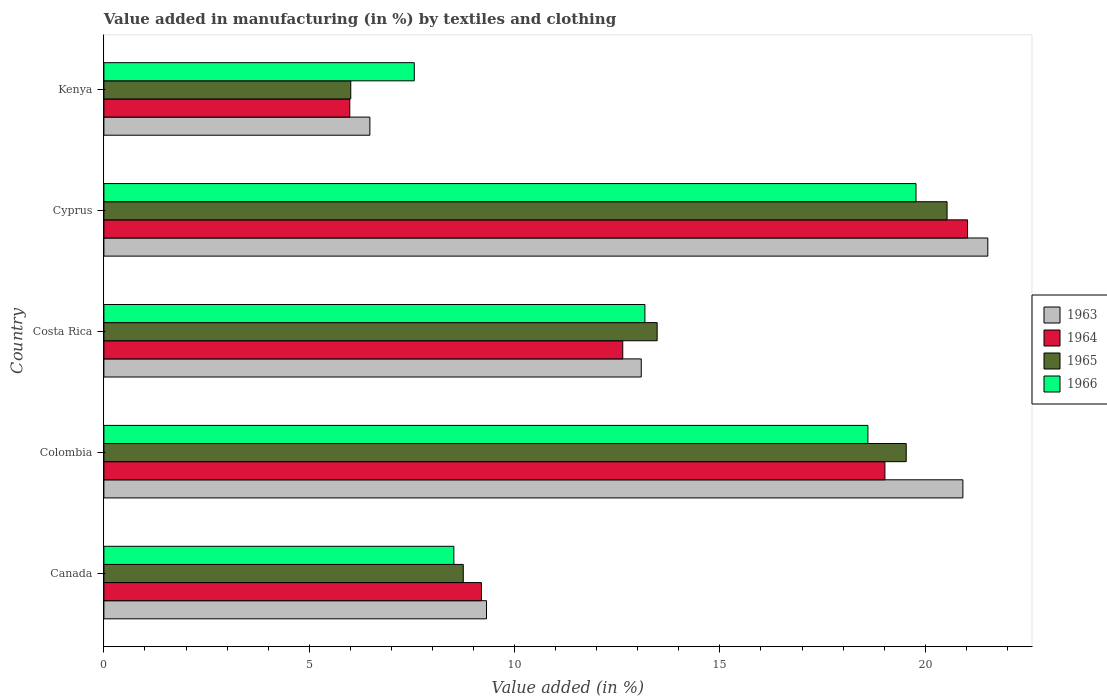How many groups of bars are there?
Make the answer very short. 5. Are the number of bars per tick equal to the number of legend labels?
Keep it short and to the point. Yes. How many bars are there on the 1st tick from the top?
Provide a short and direct response. 4. How many bars are there on the 3rd tick from the bottom?
Offer a very short reply. 4. What is the percentage of value added in manufacturing by textiles and clothing in 1963 in Canada?
Provide a short and direct response. 9.32. Across all countries, what is the maximum percentage of value added in manufacturing by textiles and clothing in 1963?
Provide a succinct answer. 21.52. Across all countries, what is the minimum percentage of value added in manufacturing by textiles and clothing in 1964?
Your answer should be compact. 5.99. In which country was the percentage of value added in manufacturing by textiles and clothing in 1965 maximum?
Give a very brief answer. Cyprus. In which country was the percentage of value added in manufacturing by textiles and clothing in 1966 minimum?
Provide a short and direct response. Kenya. What is the total percentage of value added in manufacturing by textiles and clothing in 1966 in the graph?
Your response must be concise. 67.63. What is the difference between the percentage of value added in manufacturing by textiles and clothing in 1966 in Canada and that in Colombia?
Give a very brief answer. -10.08. What is the difference between the percentage of value added in manufacturing by textiles and clothing in 1965 in Colombia and the percentage of value added in manufacturing by textiles and clothing in 1964 in Cyprus?
Offer a very short reply. -1.49. What is the average percentage of value added in manufacturing by textiles and clothing in 1963 per country?
Keep it short and to the point. 14.26. What is the difference between the percentage of value added in manufacturing by textiles and clothing in 1965 and percentage of value added in manufacturing by textiles and clothing in 1963 in Colombia?
Ensure brevity in your answer.  -1.38. What is the ratio of the percentage of value added in manufacturing by textiles and clothing in 1966 in Colombia to that in Costa Rica?
Ensure brevity in your answer.  1.41. What is the difference between the highest and the second highest percentage of value added in manufacturing by textiles and clothing in 1964?
Ensure brevity in your answer.  2.01. What is the difference between the highest and the lowest percentage of value added in manufacturing by textiles and clothing in 1963?
Your answer should be very brief. 15.05. Is it the case that in every country, the sum of the percentage of value added in manufacturing by textiles and clothing in 1965 and percentage of value added in manufacturing by textiles and clothing in 1966 is greater than the sum of percentage of value added in manufacturing by textiles and clothing in 1964 and percentage of value added in manufacturing by textiles and clothing in 1963?
Give a very brief answer. No. What does the 1st bar from the top in Colombia represents?
Keep it short and to the point. 1966. What does the 3rd bar from the bottom in Costa Rica represents?
Your answer should be very brief. 1965. Is it the case that in every country, the sum of the percentage of value added in manufacturing by textiles and clothing in 1964 and percentage of value added in manufacturing by textiles and clothing in 1963 is greater than the percentage of value added in manufacturing by textiles and clothing in 1965?
Your answer should be compact. Yes. How many bars are there?
Your response must be concise. 20. Are all the bars in the graph horizontal?
Provide a succinct answer. Yes. What is the difference between two consecutive major ticks on the X-axis?
Provide a succinct answer. 5. Are the values on the major ticks of X-axis written in scientific E-notation?
Make the answer very short. No. Does the graph contain any zero values?
Ensure brevity in your answer.  No. Where does the legend appear in the graph?
Keep it short and to the point. Center right. What is the title of the graph?
Offer a terse response. Value added in manufacturing (in %) by textiles and clothing. Does "2007" appear as one of the legend labels in the graph?
Provide a succinct answer. No. What is the label or title of the X-axis?
Keep it short and to the point. Value added (in %). What is the Value added (in %) in 1963 in Canada?
Your answer should be compact. 9.32. What is the Value added (in %) in 1964 in Canada?
Make the answer very short. 9.19. What is the Value added (in %) of 1965 in Canada?
Keep it short and to the point. 8.75. What is the Value added (in %) in 1966 in Canada?
Ensure brevity in your answer.  8.52. What is the Value added (in %) of 1963 in Colombia?
Give a very brief answer. 20.92. What is the Value added (in %) of 1964 in Colombia?
Give a very brief answer. 19.02. What is the Value added (in %) of 1965 in Colombia?
Give a very brief answer. 19.54. What is the Value added (in %) of 1966 in Colombia?
Provide a succinct answer. 18.6. What is the Value added (in %) of 1963 in Costa Rica?
Give a very brief answer. 13.08. What is the Value added (in %) in 1964 in Costa Rica?
Offer a terse response. 12.63. What is the Value added (in %) in 1965 in Costa Rica?
Provide a succinct answer. 13.47. What is the Value added (in %) of 1966 in Costa Rica?
Make the answer very short. 13.17. What is the Value added (in %) in 1963 in Cyprus?
Your answer should be compact. 21.52. What is the Value added (in %) of 1964 in Cyprus?
Provide a short and direct response. 21.03. What is the Value added (in %) in 1965 in Cyprus?
Keep it short and to the point. 20.53. What is the Value added (in %) in 1966 in Cyprus?
Provide a short and direct response. 19.78. What is the Value added (in %) of 1963 in Kenya?
Offer a terse response. 6.48. What is the Value added (in %) of 1964 in Kenya?
Provide a short and direct response. 5.99. What is the Value added (in %) in 1965 in Kenya?
Provide a succinct answer. 6.01. What is the Value added (in %) in 1966 in Kenya?
Keep it short and to the point. 7.56. Across all countries, what is the maximum Value added (in %) of 1963?
Provide a short and direct response. 21.52. Across all countries, what is the maximum Value added (in %) in 1964?
Your answer should be compact. 21.03. Across all countries, what is the maximum Value added (in %) in 1965?
Offer a very short reply. 20.53. Across all countries, what is the maximum Value added (in %) of 1966?
Your answer should be very brief. 19.78. Across all countries, what is the minimum Value added (in %) of 1963?
Keep it short and to the point. 6.48. Across all countries, what is the minimum Value added (in %) of 1964?
Offer a very short reply. 5.99. Across all countries, what is the minimum Value added (in %) in 1965?
Make the answer very short. 6.01. Across all countries, what is the minimum Value added (in %) of 1966?
Offer a terse response. 7.56. What is the total Value added (in %) of 1963 in the graph?
Offer a very short reply. 71.32. What is the total Value added (in %) in 1964 in the graph?
Ensure brevity in your answer.  67.86. What is the total Value added (in %) in 1965 in the graph?
Offer a very short reply. 68.3. What is the total Value added (in %) in 1966 in the graph?
Keep it short and to the point. 67.63. What is the difference between the Value added (in %) of 1963 in Canada and that in Colombia?
Offer a terse response. -11.6. What is the difference between the Value added (in %) of 1964 in Canada and that in Colombia?
Your answer should be compact. -9.82. What is the difference between the Value added (in %) of 1965 in Canada and that in Colombia?
Your response must be concise. -10.79. What is the difference between the Value added (in %) in 1966 in Canada and that in Colombia?
Provide a short and direct response. -10.08. What is the difference between the Value added (in %) of 1963 in Canada and that in Costa Rica?
Your answer should be compact. -3.77. What is the difference between the Value added (in %) in 1964 in Canada and that in Costa Rica?
Offer a very short reply. -3.44. What is the difference between the Value added (in %) of 1965 in Canada and that in Costa Rica?
Offer a terse response. -4.72. What is the difference between the Value added (in %) in 1966 in Canada and that in Costa Rica?
Give a very brief answer. -4.65. What is the difference between the Value added (in %) in 1963 in Canada and that in Cyprus?
Your response must be concise. -12.21. What is the difference between the Value added (in %) in 1964 in Canada and that in Cyprus?
Give a very brief answer. -11.84. What is the difference between the Value added (in %) of 1965 in Canada and that in Cyprus?
Give a very brief answer. -11.78. What is the difference between the Value added (in %) of 1966 in Canada and that in Cyprus?
Provide a short and direct response. -11.25. What is the difference between the Value added (in %) in 1963 in Canada and that in Kenya?
Offer a very short reply. 2.84. What is the difference between the Value added (in %) in 1964 in Canada and that in Kenya?
Provide a short and direct response. 3.21. What is the difference between the Value added (in %) of 1965 in Canada and that in Kenya?
Keep it short and to the point. 2.74. What is the difference between the Value added (in %) of 1966 in Canada and that in Kenya?
Your answer should be compact. 0.96. What is the difference between the Value added (in %) of 1963 in Colombia and that in Costa Rica?
Ensure brevity in your answer.  7.83. What is the difference between the Value added (in %) in 1964 in Colombia and that in Costa Rica?
Ensure brevity in your answer.  6.38. What is the difference between the Value added (in %) of 1965 in Colombia and that in Costa Rica?
Ensure brevity in your answer.  6.06. What is the difference between the Value added (in %) of 1966 in Colombia and that in Costa Rica?
Give a very brief answer. 5.43. What is the difference between the Value added (in %) in 1963 in Colombia and that in Cyprus?
Your answer should be very brief. -0.61. What is the difference between the Value added (in %) in 1964 in Colombia and that in Cyprus?
Provide a short and direct response. -2.01. What is the difference between the Value added (in %) in 1965 in Colombia and that in Cyprus?
Your answer should be very brief. -0.99. What is the difference between the Value added (in %) of 1966 in Colombia and that in Cyprus?
Your answer should be compact. -1.17. What is the difference between the Value added (in %) of 1963 in Colombia and that in Kenya?
Give a very brief answer. 14.44. What is the difference between the Value added (in %) in 1964 in Colombia and that in Kenya?
Offer a terse response. 13.03. What is the difference between the Value added (in %) in 1965 in Colombia and that in Kenya?
Provide a succinct answer. 13.53. What is the difference between the Value added (in %) in 1966 in Colombia and that in Kenya?
Provide a succinct answer. 11.05. What is the difference between the Value added (in %) of 1963 in Costa Rica and that in Cyprus?
Your answer should be compact. -8.44. What is the difference between the Value added (in %) of 1964 in Costa Rica and that in Cyprus?
Keep it short and to the point. -8.4. What is the difference between the Value added (in %) in 1965 in Costa Rica and that in Cyprus?
Your response must be concise. -7.06. What is the difference between the Value added (in %) in 1966 in Costa Rica and that in Cyprus?
Your response must be concise. -6.6. What is the difference between the Value added (in %) in 1963 in Costa Rica and that in Kenya?
Ensure brevity in your answer.  6.61. What is the difference between the Value added (in %) of 1964 in Costa Rica and that in Kenya?
Offer a very short reply. 6.65. What is the difference between the Value added (in %) of 1965 in Costa Rica and that in Kenya?
Ensure brevity in your answer.  7.46. What is the difference between the Value added (in %) of 1966 in Costa Rica and that in Kenya?
Ensure brevity in your answer.  5.62. What is the difference between the Value added (in %) of 1963 in Cyprus and that in Kenya?
Provide a short and direct response. 15.05. What is the difference between the Value added (in %) of 1964 in Cyprus and that in Kenya?
Keep it short and to the point. 15.04. What is the difference between the Value added (in %) in 1965 in Cyprus and that in Kenya?
Your answer should be very brief. 14.52. What is the difference between the Value added (in %) of 1966 in Cyprus and that in Kenya?
Offer a very short reply. 12.22. What is the difference between the Value added (in %) of 1963 in Canada and the Value added (in %) of 1964 in Colombia?
Your answer should be compact. -9.7. What is the difference between the Value added (in %) in 1963 in Canada and the Value added (in %) in 1965 in Colombia?
Your answer should be compact. -10.22. What is the difference between the Value added (in %) of 1963 in Canada and the Value added (in %) of 1966 in Colombia?
Offer a terse response. -9.29. What is the difference between the Value added (in %) in 1964 in Canada and the Value added (in %) in 1965 in Colombia?
Provide a short and direct response. -10.34. What is the difference between the Value added (in %) in 1964 in Canada and the Value added (in %) in 1966 in Colombia?
Offer a very short reply. -9.41. What is the difference between the Value added (in %) in 1965 in Canada and the Value added (in %) in 1966 in Colombia?
Offer a very short reply. -9.85. What is the difference between the Value added (in %) of 1963 in Canada and the Value added (in %) of 1964 in Costa Rica?
Offer a terse response. -3.32. What is the difference between the Value added (in %) of 1963 in Canada and the Value added (in %) of 1965 in Costa Rica?
Offer a very short reply. -4.16. What is the difference between the Value added (in %) of 1963 in Canada and the Value added (in %) of 1966 in Costa Rica?
Provide a short and direct response. -3.86. What is the difference between the Value added (in %) in 1964 in Canada and the Value added (in %) in 1965 in Costa Rica?
Your answer should be very brief. -4.28. What is the difference between the Value added (in %) of 1964 in Canada and the Value added (in %) of 1966 in Costa Rica?
Your answer should be compact. -3.98. What is the difference between the Value added (in %) of 1965 in Canada and the Value added (in %) of 1966 in Costa Rica?
Your response must be concise. -4.42. What is the difference between the Value added (in %) of 1963 in Canada and the Value added (in %) of 1964 in Cyprus?
Your response must be concise. -11.71. What is the difference between the Value added (in %) in 1963 in Canada and the Value added (in %) in 1965 in Cyprus?
Your answer should be very brief. -11.21. What is the difference between the Value added (in %) in 1963 in Canada and the Value added (in %) in 1966 in Cyprus?
Ensure brevity in your answer.  -10.46. What is the difference between the Value added (in %) in 1964 in Canada and the Value added (in %) in 1965 in Cyprus?
Your answer should be compact. -11.34. What is the difference between the Value added (in %) in 1964 in Canada and the Value added (in %) in 1966 in Cyprus?
Ensure brevity in your answer.  -10.58. What is the difference between the Value added (in %) of 1965 in Canada and the Value added (in %) of 1966 in Cyprus?
Provide a short and direct response. -11.02. What is the difference between the Value added (in %) in 1963 in Canada and the Value added (in %) in 1964 in Kenya?
Keep it short and to the point. 3.33. What is the difference between the Value added (in %) in 1963 in Canada and the Value added (in %) in 1965 in Kenya?
Keep it short and to the point. 3.31. What is the difference between the Value added (in %) in 1963 in Canada and the Value added (in %) in 1966 in Kenya?
Provide a short and direct response. 1.76. What is the difference between the Value added (in %) of 1964 in Canada and the Value added (in %) of 1965 in Kenya?
Ensure brevity in your answer.  3.18. What is the difference between the Value added (in %) of 1964 in Canada and the Value added (in %) of 1966 in Kenya?
Keep it short and to the point. 1.64. What is the difference between the Value added (in %) of 1965 in Canada and the Value added (in %) of 1966 in Kenya?
Offer a very short reply. 1.19. What is the difference between the Value added (in %) of 1963 in Colombia and the Value added (in %) of 1964 in Costa Rica?
Make the answer very short. 8.28. What is the difference between the Value added (in %) in 1963 in Colombia and the Value added (in %) in 1965 in Costa Rica?
Your response must be concise. 7.44. What is the difference between the Value added (in %) of 1963 in Colombia and the Value added (in %) of 1966 in Costa Rica?
Your answer should be very brief. 7.74. What is the difference between the Value added (in %) of 1964 in Colombia and the Value added (in %) of 1965 in Costa Rica?
Offer a very short reply. 5.55. What is the difference between the Value added (in %) in 1964 in Colombia and the Value added (in %) in 1966 in Costa Rica?
Offer a very short reply. 5.84. What is the difference between the Value added (in %) in 1965 in Colombia and the Value added (in %) in 1966 in Costa Rica?
Provide a short and direct response. 6.36. What is the difference between the Value added (in %) of 1963 in Colombia and the Value added (in %) of 1964 in Cyprus?
Give a very brief answer. -0.11. What is the difference between the Value added (in %) of 1963 in Colombia and the Value added (in %) of 1965 in Cyprus?
Offer a very short reply. 0.39. What is the difference between the Value added (in %) of 1963 in Colombia and the Value added (in %) of 1966 in Cyprus?
Your response must be concise. 1.14. What is the difference between the Value added (in %) of 1964 in Colombia and the Value added (in %) of 1965 in Cyprus?
Provide a succinct answer. -1.51. What is the difference between the Value added (in %) in 1964 in Colombia and the Value added (in %) in 1966 in Cyprus?
Your response must be concise. -0.76. What is the difference between the Value added (in %) in 1965 in Colombia and the Value added (in %) in 1966 in Cyprus?
Make the answer very short. -0.24. What is the difference between the Value added (in %) of 1963 in Colombia and the Value added (in %) of 1964 in Kenya?
Ensure brevity in your answer.  14.93. What is the difference between the Value added (in %) in 1963 in Colombia and the Value added (in %) in 1965 in Kenya?
Make the answer very short. 14.91. What is the difference between the Value added (in %) in 1963 in Colombia and the Value added (in %) in 1966 in Kenya?
Offer a terse response. 13.36. What is the difference between the Value added (in %) in 1964 in Colombia and the Value added (in %) in 1965 in Kenya?
Your answer should be compact. 13.01. What is the difference between the Value added (in %) in 1964 in Colombia and the Value added (in %) in 1966 in Kenya?
Provide a short and direct response. 11.46. What is the difference between the Value added (in %) of 1965 in Colombia and the Value added (in %) of 1966 in Kenya?
Your response must be concise. 11.98. What is the difference between the Value added (in %) of 1963 in Costa Rica and the Value added (in %) of 1964 in Cyprus?
Provide a short and direct response. -7.95. What is the difference between the Value added (in %) of 1963 in Costa Rica and the Value added (in %) of 1965 in Cyprus?
Keep it short and to the point. -7.45. What is the difference between the Value added (in %) of 1963 in Costa Rica and the Value added (in %) of 1966 in Cyprus?
Provide a succinct answer. -6.69. What is the difference between the Value added (in %) in 1964 in Costa Rica and the Value added (in %) in 1965 in Cyprus?
Provide a short and direct response. -7.9. What is the difference between the Value added (in %) in 1964 in Costa Rica and the Value added (in %) in 1966 in Cyprus?
Offer a terse response. -7.14. What is the difference between the Value added (in %) in 1965 in Costa Rica and the Value added (in %) in 1966 in Cyprus?
Make the answer very short. -6.3. What is the difference between the Value added (in %) of 1963 in Costa Rica and the Value added (in %) of 1964 in Kenya?
Give a very brief answer. 7.1. What is the difference between the Value added (in %) in 1963 in Costa Rica and the Value added (in %) in 1965 in Kenya?
Ensure brevity in your answer.  7.07. What is the difference between the Value added (in %) of 1963 in Costa Rica and the Value added (in %) of 1966 in Kenya?
Your answer should be compact. 5.53. What is the difference between the Value added (in %) of 1964 in Costa Rica and the Value added (in %) of 1965 in Kenya?
Offer a terse response. 6.62. What is the difference between the Value added (in %) of 1964 in Costa Rica and the Value added (in %) of 1966 in Kenya?
Make the answer very short. 5.08. What is the difference between the Value added (in %) in 1965 in Costa Rica and the Value added (in %) in 1966 in Kenya?
Keep it short and to the point. 5.91. What is the difference between the Value added (in %) of 1963 in Cyprus and the Value added (in %) of 1964 in Kenya?
Provide a succinct answer. 15.54. What is the difference between the Value added (in %) of 1963 in Cyprus and the Value added (in %) of 1965 in Kenya?
Your answer should be very brief. 15.51. What is the difference between the Value added (in %) in 1963 in Cyprus and the Value added (in %) in 1966 in Kenya?
Keep it short and to the point. 13.97. What is the difference between the Value added (in %) of 1964 in Cyprus and the Value added (in %) of 1965 in Kenya?
Offer a terse response. 15.02. What is the difference between the Value added (in %) of 1964 in Cyprus and the Value added (in %) of 1966 in Kenya?
Offer a very short reply. 13.47. What is the difference between the Value added (in %) in 1965 in Cyprus and the Value added (in %) in 1966 in Kenya?
Your response must be concise. 12.97. What is the average Value added (in %) of 1963 per country?
Offer a terse response. 14.26. What is the average Value added (in %) in 1964 per country?
Keep it short and to the point. 13.57. What is the average Value added (in %) of 1965 per country?
Offer a very short reply. 13.66. What is the average Value added (in %) in 1966 per country?
Provide a short and direct response. 13.53. What is the difference between the Value added (in %) in 1963 and Value added (in %) in 1964 in Canada?
Provide a short and direct response. 0.12. What is the difference between the Value added (in %) in 1963 and Value added (in %) in 1965 in Canada?
Your answer should be very brief. 0.57. What is the difference between the Value added (in %) of 1963 and Value added (in %) of 1966 in Canada?
Offer a very short reply. 0.8. What is the difference between the Value added (in %) of 1964 and Value added (in %) of 1965 in Canada?
Your answer should be compact. 0.44. What is the difference between the Value added (in %) of 1964 and Value added (in %) of 1966 in Canada?
Give a very brief answer. 0.67. What is the difference between the Value added (in %) in 1965 and Value added (in %) in 1966 in Canada?
Keep it short and to the point. 0.23. What is the difference between the Value added (in %) of 1963 and Value added (in %) of 1964 in Colombia?
Offer a very short reply. 1.9. What is the difference between the Value added (in %) in 1963 and Value added (in %) in 1965 in Colombia?
Ensure brevity in your answer.  1.38. What is the difference between the Value added (in %) in 1963 and Value added (in %) in 1966 in Colombia?
Provide a short and direct response. 2.31. What is the difference between the Value added (in %) in 1964 and Value added (in %) in 1965 in Colombia?
Make the answer very short. -0.52. What is the difference between the Value added (in %) in 1964 and Value added (in %) in 1966 in Colombia?
Provide a short and direct response. 0.41. What is the difference between the Value added (in %) in 1965 and Value added (in %) in 1966 in Colombia?
Offer a terse response. 0.93. What is the difference between the Value added (in %) of 1963 and Value added (in %) of 1964 in Costa Rica?
Provide a succinct answer. 0.45. What is the difference between the Value added (in %) in 1963 and Value added (in %) in 1965 in Costa Rica?
Provide a succinct answer. -0.39. What is the difference between the Value added (in %) of 1963 and Value added (in %) of 1966 in Costa Rica?
Keep it short and to the point. -0.09. What is the difference between the Value added (in %) in 1964 and Value added (in %) in 1965 in Costa Rica?
Your answer should be very brief. -0.84. What is the difference between the Value added (in %) of 1964 and Value added (in %) of 1966 in Costa Rica?
Ensure brevity in your answer.  -0.54. What is the difference between the Value added (in %) in 1965 and Value added (in %) in 1966 in Costa Rica?
Offer a terse response. 0.3. What is the difference between the Value added (in %) in 1963 and Value added (in %) in 1964 in Cyprus?
Your answer should be compact. 0.49. What is the difference between the Value added (in %) of 1963 and Value added (in %) of 1965 in Cyprus?
Provide a short and direct response. 0.99. What is the difference between the Value added (in %) in 1963 and Value added (in %) in 1966 in Cyprus?
Give a very brief answer. 1.75. What is the difference between the Value added (in %) of 1964 and Value added (in %) of 1965 in Cyprus?
Provide a succinct answer. 0.5. What is the difference between the Value added (in %) of 1964 and Value added (in %) of 1966 in Cyprus?
Give a very brief answer. 1.25. What is the difference between the Value added (in %) in 1965 and Value added (in %) in 1966 in Cyprus?
Give a very brief answer. 0.76. What is the difference between the Value added (in %) in 1963 and Value added (in %) in 1964 in Kenya?
Your response must be concise. 0.49. What is the difference between the Value added (in %) of 1963 and Value added (in %) of 1965 in Kenya?
Your answer should be compact. 0.47. What is the difference between the Value added (in %) in 1963 and Value added (in %) in 1966 in Kenya?
Keep it short and to the point. -1.08. What is the difference between the Value added (in %) of 1964 and Value added (in %) of 1965 in Kenya?
Give a very brief answer. -0.02. What is the difference between the Value added (in %) in 1964 and Value added (in %) in 1966 in Kenya?
Provide a succinct answer. -1.57. What is the difference between the Value added (in %) of 1965 and Value added (in %) of 1966 in Kenya?
Give a very brief answer. -1.55. What is the ratio of the Value added (in %) in 1963 in Canada to that in Colombia?
Provide a succinct answer. 0.45. What is the ratio of the Value added (in %) of 1964 in Canada to that in Colombia?
Your response must be concise. 0.48. What is the ratio of the Value added (in %) in 1965 in Canada to that in Colombia?
Offer a very short reply. 0.45. What is the ratio of the Value added (in %) in 1966 in Canada to that in Colombia?
Provide a short and direct response. 0.46. What is the ratio of the Value added (in %) of 1963 in Canada to that in Costa Rica?
Your answer should be compact. 0.71. What is the ratio of the Value added (in %) of 1964 in Canada to that in Costa Rica?
Keep it short and to the point. 0.73. What is the ratio of the Value added (in %) of 1965 in Canada to that in Costa Rica?
Make the answer very short. 0.65. What is the ratio of the Value added (in %) of 1966 in Canada to that in Costa Rica?
Your answer should be compact. 0.65. What is the ratio of the Value added (in %) in 1963 in Canada to that in Cyprus?
Give a very brief answer. 0.43. What is the ratio of the Value added (in %) in 1964 in Canada to that in Cyprus?
Provide a short and direct response. 0.44. What is the ratio of the Value added (in %) in 1965 in Canada to that in Cyprus?
Provide a succinct answer. 0.43. What is the ratio of the Value added (in %) in 1966 in Canada to that in Cyprus?
Offer a terse response. 0.43. What is the ratio of the Value added (in %) in 1963 in Canada to that in Kenya?
Provide a succinct answer. 1.44. What is the ratio of the Value added (in %) of 1964 in Canada to that in Kenya?
Your answer should be compact. 1.54. What is the ratio of the Value added (in %) in 1965 in Canada to that in Kenya?
Your response must be concise. 1.46. What is the ratio of the Value added (in %) in 1966 in Canada to that in Kenya?
Your answer should be very brief. 1.13. What is the ratio of the Value added (in %) of 1963 in Colombia to that in Costa Rica?
Your response must be concise. 1.6. What is the ratio of the Value added (in %) of 1964 in Colombia to that in Costa Rica?
Your answer should be compact. 1.51. What is the ratio of the Value added (in %) in 1965 in Colombia to that in Costa Rica?
Your answer should be compact. 1.45. What is the ratio of the Value added (in %) in 1966 in Colombia to that in Costa Rica?
Provide a succinct answer. 1.41. What is the ratio of the Value added (in %) of 1963 in Colombia to that in Cyprus?
Keep it short and to the point. 0.97. What is the ratio of the Value added (in %) in 1964 in Colombia to that in Cyprus?
Make the answer very short. 0.9. What is the ratio of the Value added (in %) in 1965 in Colombia to that in Cyprus?
Your answer should be very brief. 0.95. What is the ratio of the Value added (in %) in 1966 in Colombia to that in Cyprus?
Keep it short and to the point. 0.94. What is the ratio of the Value added (in %) of 1963 in Colombia to that in Kenya?
Provide a succinct answer. 3.23. What is the ratio of the Value added (in %) of 1964 in Colombia to that in Kenya?
Your answer should be compact. 3.18. What is the ratio of the Value added (in %) in 1965 in Colombia to that in Kenya?
Give a very brief answer. 3.25. What is the ratio of the Value added (in %) in 1966 in Colombia to that in Kenya?
Your response must be concise. 2.46. What is the ratio of the Value added (in %) of 1963 in Costa Rica to that in Cyprus?
Provide a succinct answer. 0.61. What is the ratio of the Value added (in %) of 1964 in Costa Rica to that in Cyprus?
Provide a succinct answer. 0.6. What is the ratio of the Value added (in %) in 1965 in Costa Rica to that in Cyprus?
Provide a short and direct response. 0.66. What is the ratio of the Value added (in %) of 1966 in Costa Rica to that in Cyprus?
Keep it short and to the point. 0.67. What is the ratio of the Value added (in %) in 1963 in Costa Rica to that in Kenya?
Ensure brevity in your answer.  2.02. What is the ratio of the Value added (in %) in 1964 in Costa Rica to that in Kenya?
Offer a terse response. 2.11. What is the ratio of the Value added (in %) in 1965 in Costa Rica to that in Kenya?
Offer a very short reply. 2.24. What is the ratio of the Value added (in %) in 1966 in Costa Rica to that in Kenya?
Keep it short and to the point. 1.74. What is the ratio of the Value added (in %) in 1963 in Cyprus to that in Kenya?
Keep it short and to the point. 3.32. What is the ratio of the Value added (in %) in 1964 in Cyprus to that in Kenya?
Make the answer very short. 3.51. What is the ratio of the Value added (in %) in 1965 in Cyprus to that in Kenya?
Offer a terse response. 3.42. What is the ratio of the Value added (in %) of 1966 in Cyprus to that in Kenya?
Provide a succinct answer. 2.62. What is the difference between the highest and the second highest Value added (in %) in 1963?
Provide a succinct answer. 0.61. What is the difference between the highest and the second highest Value added (in %) in 1964?
Your answer should be compact. 2.01. What is the difference between the highest and the second highest Value added (in %) in 1965?
Make the answer very short. 0.99. What is the difference between the highest and the second highest Value added (in %) of 1966?
Your answer should be very brief. 1.17. What is the difference between the highest and the lowest Value added (in %) of 1963?
Keep it short and to the point. 15.05. What is the difference between the highest and the lowest Value added (in %) of 1964?
Ensure brevity in your answer.  15.04. What is the difference between the highest and the lowest Value added (in %) of 1965?
Offer a terse response. 14.52. What is the difference between the highest and the lowest Value added (in %) in 1966?
Offer a terse response. 12.22. 